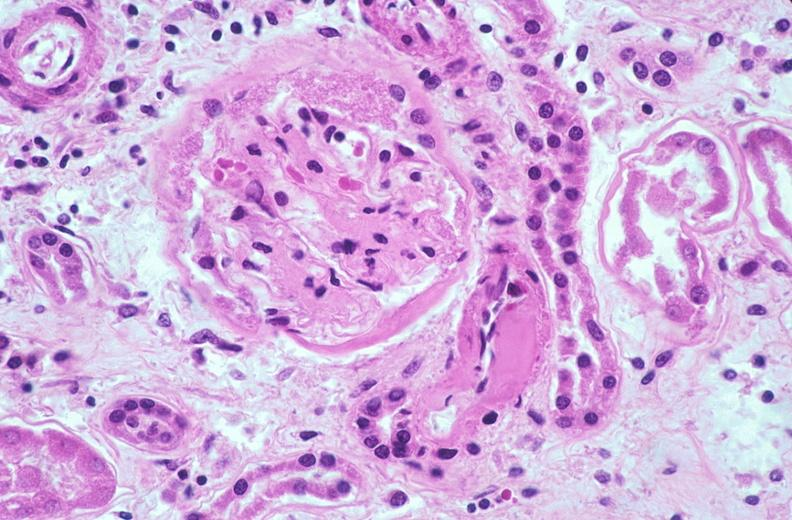why does this image show kidney glomerulus, thickened and hyalinized basement membranes fibrin caps?
Answer the question using a single word or phrase. Due to diabetes mellitus 